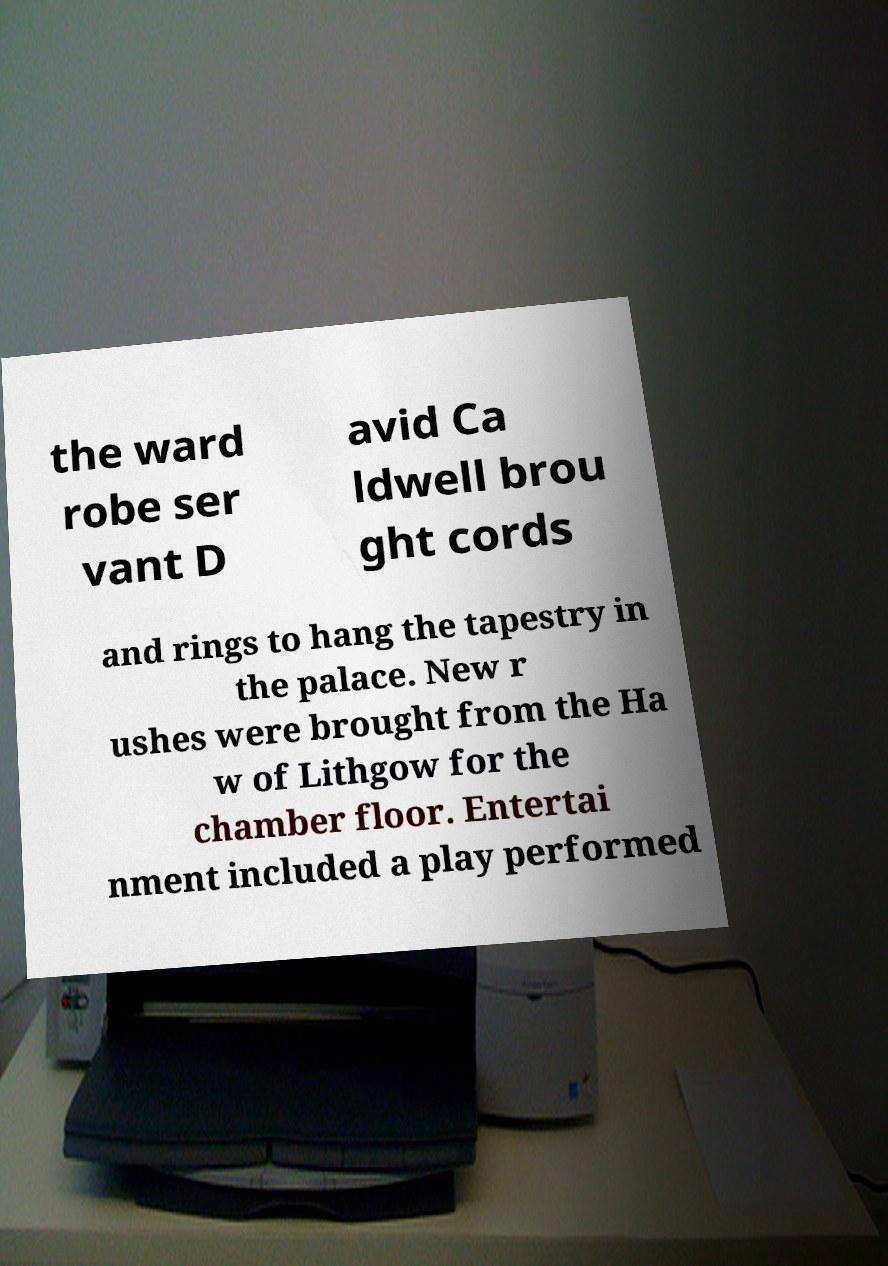Please identify and transcribe the text found in this image. the ward robe ser vant D avid Ca ldwell brou ght cords and rings to hang the tapestry in the palace. New r ushes were brought from the Ha w of Lithgow for the chamber floor. Entertai nment included a play performed 